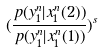Convert formula to latex. <formula><loc_0><loc_0><loc_500><loc_500>( \frac { p ( y _ { 1 } ^ { n } | x _ { 1 } ^ { n } ( 2 ) ) } { p ( y _ { 1 } ^ { n } | x _ { 1 } ^ { n } ( 1 ) ) } ) ^ { s }</formula> 